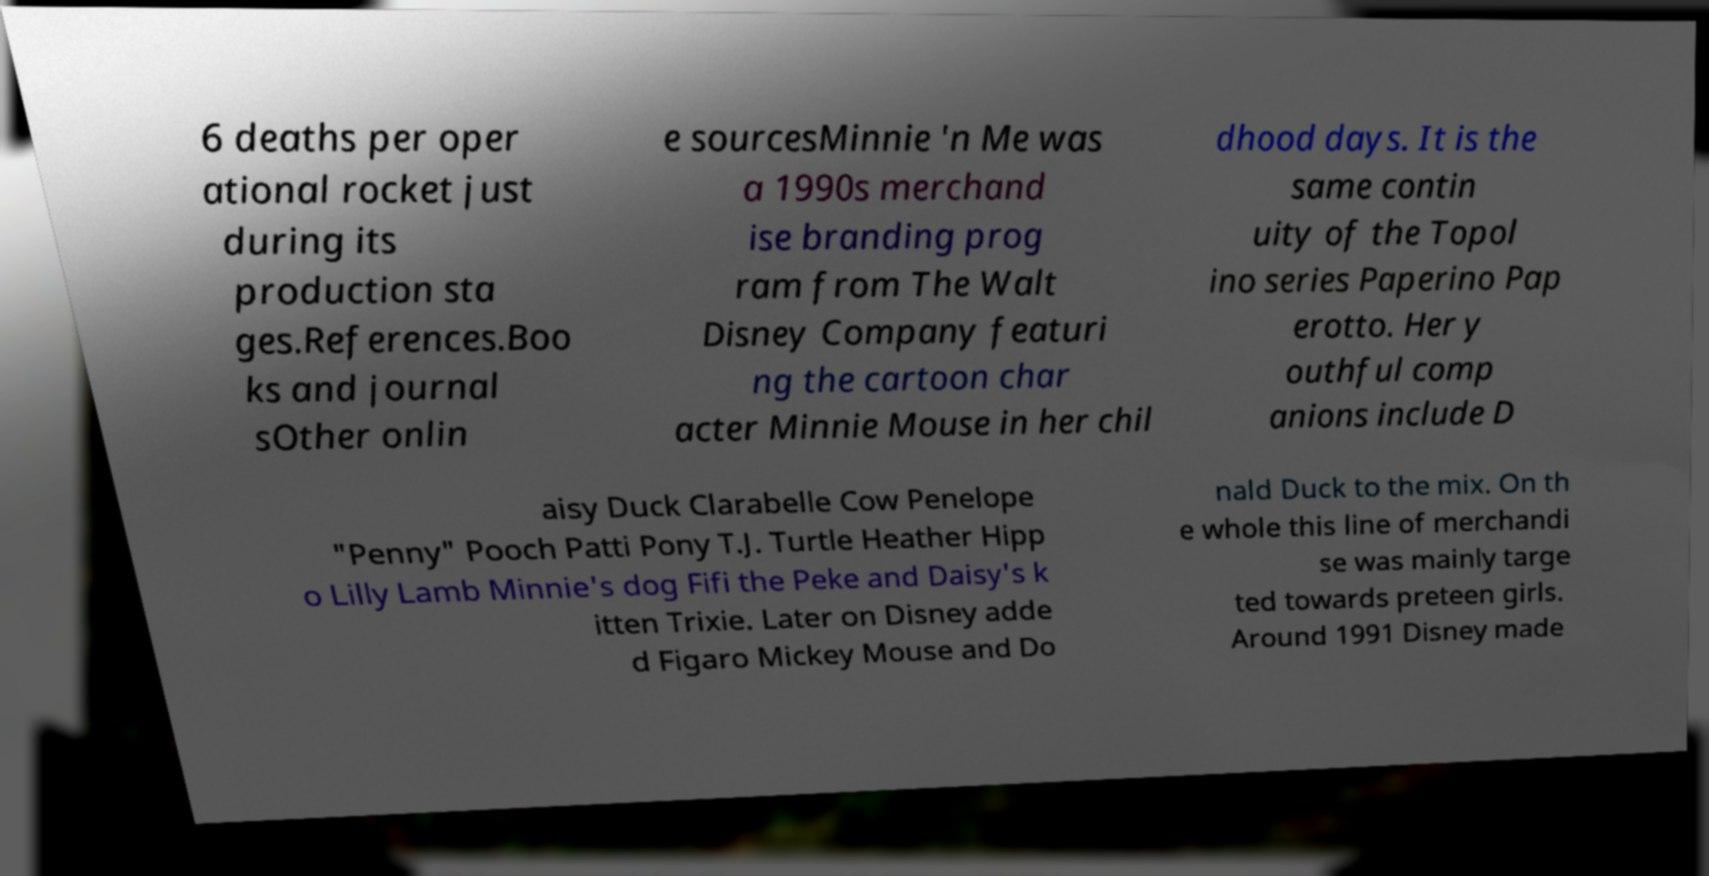There's text embedded in this image that I need extracted. Can you transcribe it verbatim? 6 deaths per oper ational rocket just during its production sta ges.References.Boo ks and journal sOther onlin e sourcesMinnie 'n Me was a 1990s merchand ise branding prog ram from The Walt Disney Company featuri ng the cartoon char acter Minnie Mouse in her chil dhood days. It is the same contin uity of the Topol ino series Paperino Pap erotto. Her y outhful comp anions include D aisy Duck Clarabelle Cow Penelope "Penny" Pooch Patti Pony T.J. Turtle Heather Hipp o Lilly Lamb Minnie's dog Fifi the Peke and Daisy's k itten Trixie. Later on Disney adde d Figaro Mickey Mouse and Do nald Duck to the mix. On th e whole this line of merchandi se was mainly targe ted towards preteen girls. Around 1991 Disney made 